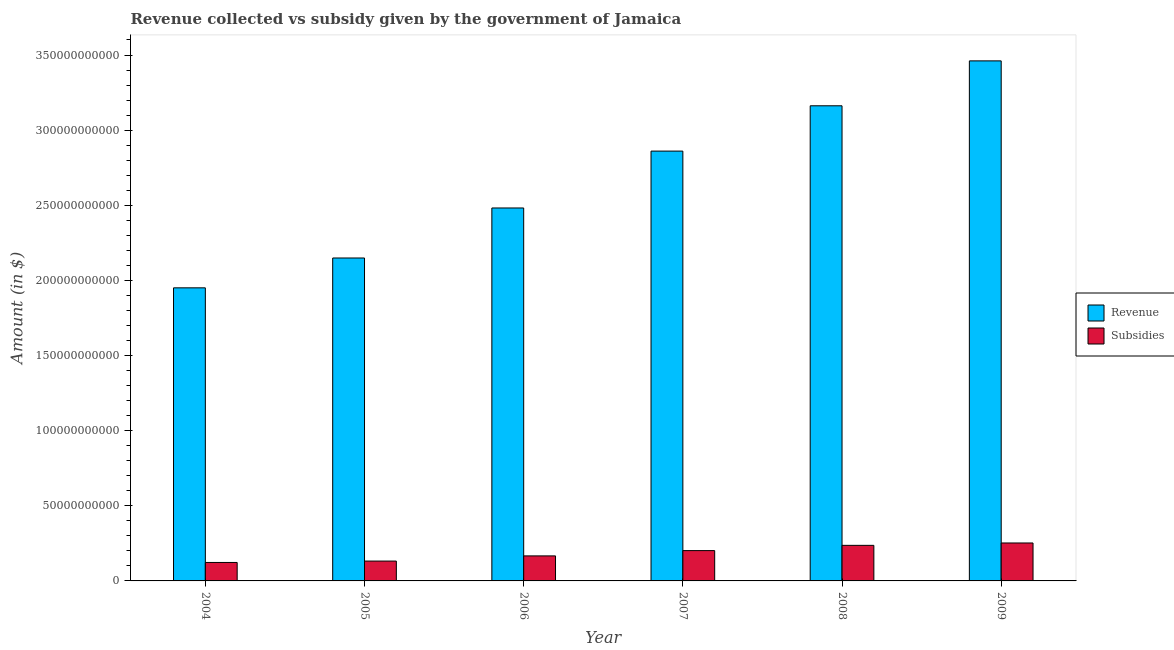How many groups of bars are there?
Offer a very short reply. 6. Are the number of bars per tick equal to the number of legend labels?
Give a very brief answer. Yes. How many bars are there on the 1st tick from the left?
Your answer should be very brief. 2. In how many cases, is the number of bars for a given year not equal to the number of legend labels?
Your answer should be very brief. 0. What is the amount of revenue collected in 2006?
Your response must be concise. 2.48e+11. Across all years, what is the maximum amount of subsidies given?
Keep it short and to the point. 2.53e+1. Across all years, what is the minimum amount of revenue collected?
Provide a succinct answer. 1.95e+11. In which year was the amount of subsidies given maximum?
Offer a terse response. 2009. In which year was the amount of revenue collected minimum?
Ensure brevity in your answer.  2004. What is the total amount of subsidies given in the graph?
Ensure brevity in your answer.  1.11e+11. What is the difference between the amount of subsidies given in 2007 and that in 2008?
Give a very brief answer. -3.50e+09. What is the difference between the amount of subsidies given in 2009 and the amount of revenue collected in 2006?
Your answer should be very brief. 8.60e+09. What is the average amount of subsidies given per year?
Keep it short and to the point. 1.85e+1. In how many years, is the amount of subsidies given greater than 350000000000 $?
Provide a short and direct response. 0. What is the ratio of the amount of revenue collected in 2007 to that in 2009?
Offer a very short reply. 0.83. What is the difference between the highest and the second highest amount of subsidies given?
Offer a terse response. 1.58e+09. What is the difference between the highest and the lowest amount of subsidies given?
Your response must be concise. 1.30e+1. In how many years, is the amount of revenue collected greater than the average amount of revenue collected taken over all years?
Make the answer very short. 3. Is the sum of the amount of revenue collected in 2004 and 2007 greater than the maximum amount of subsidies given across all years?
Provide a short and direct response. Yes. What does the 1st bar from the left in 2008 represents?
Your answer should be very brief. Revenue. What does the 1st bar from the right in 2004 represents?
Make the answer very short. Subsidies. How many bars are there?
Your answer should be very brief. 12. Are all the bars in the graph horizontal?
Offer a terse response. No. How many years are there in the graph?
Ensure brevity in your answer.  6. What is the difference between two consecutive major ticks on the Y-axis?
Provide a succinct answer. 5.00e+1. Does the graph contain any zero values?
Ensure brevity in your answer.  No. What is the title of the graph?
Provide a succinct answer. Revenue collected vs subsidy given by the government of Jamaica. Does "Revenue" appear as one of the legend labels in the graph?
Offer a terse response. Yes. What is the label or title of the X-axis?
Make the answer very short. Year. What is the label or title of the Y-axis?
Give a very brief answer. Amount (in $). What is the Amount (in $) of Revenue in 2004?
Offer a very short reply. 1.95e+11. What is the Amount (in $) of Subsidies in 2004?
Make the answer very short. 1.23e+1. What is the Amount (in $) in Revenue in 2005?
Provide a short and direct response. 2.15e+11. What is the Amount (in $) in Subsidies in 2005?
Make the answer very short. 1.32e+1. What is the Amount (in $) in Revenue in 2006?
Ensure brevity in your answer.  2.48e+11. What is the Amount (in $) in Subsidies in 2006?
Keep it short and to the point. 1.67e+1. What is the Amount (in $) of Revenue in 2007?
Your answer should be very brief. 2.86e+11. What is the Amount (in $) of Subsidies in 2007?
Give a very brief answer. 2.02e+1. What is the Amount (in $) in Revenue in 2008?
Provide a short and direct response. 3.16e+11. What is the Amount (in $) of Subsidies in 2008?
Offer a terse response. 2.37e+1. What is the Amount (in $) in Revenue in 2009?
Make the answer very short. 3.46e+11. What is the Amount (in $) of Subsidies in 2009?
Your answer should be compact. 2.53e+1. Across all years, what is the maximum Amount (in $) of Revenue?
Provide a short and direct response. 3.46e+11. Across all years, what is the maximum Amount (in $) in Subsidies?
Ensure brevity in your answer.  2.53e+1. Across all years, what is the minimum Amount (in $) of Revenue?
Provide a short and direct response. 1.95e+11. Across all years, what is the minimum Amount (in $) in Subsidies?
Make the answer very short. 1.23e+1. What is the total Amount (in $) in Revenue in the graph?
Provide a short and direct response. 1.61e+12. What is the total Amount (in $) in Subsidies in the graph?
Give a very brief answer. 1.11e+11. What is the difference between the Amount (in $) of Revenue in 2004 and that in 2005?
Your answer should be compact. -1.99e+1. What is the difference between the Amount (in $) of Subsidies in 2004 and that in 2005?
Offer a terse response. -9.25e+08. What is the difference between the Amount (in $) of Revenue in 2004 and that in 2006?
Offer a very short reply. -5.32e+1. What is the difference between the Amount (in $) in Subsidies in 2004 and that in 2006?
Your answer should be compact. -4.37e+09. What is the difference between the Amount (in $) of Revenue in 2004 and that in 2007?
Keep it short and to the point. -9.10e+1. What is the difference between the Amount (in $) of Subsidies in 2004 and that in 2007?
Your answer should be very brief. -7.89e+09. What is the difference between the Amount (in $) in Revenue in 2004 and that in 2008?
Your answer should be very brief. -1.21e+11. What is the difference between the Amount (in $) in Subsidies in 2004 and that in 2008?
Offer a terse response. -1.14e+1. What is the difference between the Amount (in $) in Revenue in 2004 and that in 2009?
Make the answer very short. -1.51e+11. What is the difference between the Amount (in $) in Subsidies in 2004 and that in 2009?
Make the answer very short. -1.30e+1. What is the difference between the Amount (in $) of Revenue in 2005 and that in 2006?
Provide a succinct answer. -3.33e+1. What is the difference between the Amount (in $) of Subsidies in 2005 and that in 2006?
Keep it short and to the point. -3.44e+09. What is the difference between the Amount (in $) of Revenue in 2005 and that in 2007?
Provide a succinct answer. -7.11e+1. What is the difference between the Amount (in $) in Subsidies in 2005 and that in 2007?
Ensure brevity in your answer.  -6.96e+09. What is the difference between the Amount (in $) of Revenue in 2005 and that in 2008?
Give a very brief answer. -1.01e+11. What is the difference between the Amount (in $) in Subsidies in 2005 and that in 2008?
Keep it short and to the point. -1.05e+1. What is the difference between the Amount (in $) in Revenue in 2005 and that in 2009?
Ensure brevity in your answer.  -1.31e+11. What is the difference between the Amount (in $) of Subsidies in 2005 and that in 2009?
Ensure brevity in your answer.  -1.20e+1. What is the difference between the Amount (in $) in Revenue in 2006 and that in 2007?
Keep it short and to the point. -3.78e+1. What is the difference between the Amount (in $) in Subsidies in 2006 and that in 2007?
Provide a short and direct response. -3.52e+09. What is the difference between the Amount (in $) of Revenue in 2006 and that in 2008?
Provide a short and direct response. -6.80e+1. What is the difference between the Amount (in $) of Subsidies in 2006 and that in 2008?
Keep it short and to the point. -7.02e+09. What is the difference between the Amount (in $) in Revenue in 2006 and that in 2009?
Your response must be concise. -9.79e+1. What is the difference between the Amount (in $) of Subsidies in 2006 and that in 2009?
Offer a terse response. -8.60e+09. What is the difference between the Amount (in $) of Revenue in 2007 and that in 2008?
Your answer should be compact. -3.02e+1. What is the difference between the Amount (in $) of Subsidies in 2007 and that in 2008?
Provide a short and direct response. -3.50e+09. What is the difference between the Amount (in $) in Revenue in 2007 and that in 2009?
Provide a short and direct response. -6.01e+1. What is the difference between the Amount (in $) of Subsidies in 2007 and that in 2009?
Keep it short and to the point. -5.08e+09. What is the difference between the Amount (in $) of Revenue in 2008 and that in 2009?
Keep it short and to the point. -2.99e+1. What is the difference between the Amount (in $) in Subsidies in 2008 and that in 2009?
Your answer should be very brief. -1.58e+09. What is the difference between the Amount (in $) in Revenue in 2004 and the Amount (in $) in Subsidies in 2005?
Your answer should be compact. 1.82e+11. What is the difference between the Amount (in $) in Revenue in 2004 and the Amount (in $) in Subsidies in 2006?
Offer a very short reply. 1.78e+11. What is the difference between the Amount (in $) of Revenue in 2004 and the Amount (in $) of Subsidies in 2007?
Give a very brief answer. 1.75e+11. What is the difference between the Amount (in $) in Revenue in 2004 and the Amount (in $) in Subsidies in 2008?
Provide a succinct answer. 1.71e+11. What is the difference between the Amount (in $) in Revenue in 2004 and the Amount (in $) in Subsidies in 2009?
Your response must be concise. 1.70e+11. What is the difference between the Amount (in $) in Revenue in 2005 and the Amount (in $) in Subsidies in 2006?
Make the answer very short. 1.98e+11. What is the difference between the Amount (in $) of Revenue in 2005 and the Amount (in $) of Subsidies in 2007?
Make the answer very short. 1.95e+11. What is the difference between the Amount (in $) of Revenue in 2005 and the Amount (in $) of Subsidies in 2008?
Your response must be concise. 1.91e+11. What is the difference between the Amount (in $) in Revenue in 2005 and the Amount (in $) in Subsidies in 2009?
Provide a short and direct response. 1.90e+11. What is the difference between the Amount (in $) of Revenue in 2006 and the Amount (in $) of Subsidies in 2007?
Give a very brief answer. 2.28e+11. What is the difference between the Amount (in $) in Revenue in 2006 and the Amount (in $) in Subsidies in 2008?
Keep it short and to the point. 2.25e+11. What is the difference between the Amount (in $) of Revenue in 2006 and the Amount (in $) of Subsidies in 2009?
Ensure brevity in your answer.  2.23e+11. What is the difference between the Amount (in $) of Revenue in 2007 and the Amount (in $) of Subsidies in 2008?
Keep it short and to the point. 2.62e+11. What is the difference between the Amount (in $) of Revenue in 2007 and the Amount (in $) of Subsidies in 2009?
Ensure brevity in your answer.  2.61e+11. What is the difference between the Amount (in $) in Revenue in 2008 and the Amount (in $) in Subsidies in 2009?
Offer a terse response. 2.91e+11. What is the average Amount (in $) of Revenue per year?
Ensure brevity in your answer.  2.68e+11. What is the average Amount (in $) in Subsidies per year?
Your answer should be very brief. 1.85e+1. In the year 2004, what is the difference between the Amount (in $) of Revenue and Amount (in $) of Subsidies?
Make the answer very short. 1.83e+11. In the year 2005, what is the difference between the Amount (in $) of Revenue and Amount (in $) of Subsidies?
Your response must be concise. 2.02e+11. In the year 2006, what is the difference between the Amount (in $) in Revenue and Amount (in $) in Subsidies?
Give a very brief answer. 2.32e+11. In the year 2007, what is the difference between the Amount (in $) of Revenue and Amount (in $) of Subsidies?
Provide a succinct answer. 2.66e+11. In the year 2008, what is the difference between the Amount (in $) of Revenue and Amount (in $) of Subsidies?
Provide a short and direct response. 2.93e+11. In the year 2009, what is the difference between the Amount (in $) of Revenue and Amount (in $) of Subsidies?
Offer a very short reply. 3.21e+11. What is the ratio of the Amount (in $) of Revenue in 2004 to that in 2005?
Make the answer very short. 0.91. What is the ratio of the Amount (in $) in Revenue in 2004 to that in 2006?
Make the answer very short. 0.79. What is the ratio of the Amount (in $) in Subsidies in 2004 to that in 2006?
Provide a short and direct response. 0.74. What is the ratio of the Amount (in $) of Revenue in 2004 to that in 2007?
Offer a very short reply. 0.68. What is the ratio of the Amount (in $) in Subsidies in 2004 to that in 2007?
Offer a terse response. 0.61. What is the ratio of the Amount (in $) in Revenue in 2004 to that in 2008?
Make the answer very short. 0.62. What is the ratio of the Amount (in $) in Subsidies in 2004 to that in 2008?
Ensure brevity in your answer.  0.52. What is the ratio of the Amount (in $) of Revenue in 2004 to that in 2009?
Ensure brevity in your answer.  0.56. What is the ratio of the Amount (in $) of Subsidies in 2004 to that in 2009?
Your response must be concise. 0.49. What is the ratio of the Amount (in $) of Revenue in 2005 to that in 2006?
Keep it short and to the point. 0.87. What is the ratio of the Amount (in $) in Subsidies in 2005 to that in 2006?
Offer a terse response. 0.79. What is the ratio of the Amount (in $) in Revenue in 2005 to that in 2007?
Ensure brevity in your answer.  0.75. What is the ratio of the Amount (in $) in Subsidies in 2005 to that in 2007?
Provide a short and direct response. 0.65. What is the ratio of the Amount (in $) in Revenue in 2005 to that in 2008?
Offer a very short reply. 0.68. What is the ratio of the Amount (in $) in Subsidies in 2005 to that in 2008?
Make the answer very short. 0.56. What is the ratio of the Amount (in $) in Revenue in 2005 to that in 2009?
Your answer should be very brief. 0.62. What is the ratio of the Amount (in $) in Subsidies in 2005 to that in 2009?
Keep it short and to the point. 0.52. What is the ratio of the Amount (in $) in Revenue in 2006 to that in 2007?
Provide a short and direct response. 0.87. What is the ratio of the Amount (in $) of Subsidies in 2006 to that in 2007?
Your response must be concise. 0.83. What is the ratio of the Amount (in $) of Revenue in 2006 to that in 2008?
Keep it short and to the point. 0.78. What is the ratio of the Amount (in $) in Subsidies in 2006 to that in 2008?
Give a very brief answer. 0.7. What is the ratio of the Amount (in $) in Revenue in 2006 to that in 2009?
Give a very brief answer. 0.72. What is the ratio of the Amount (in $) in Subsidies in 2006 to that in 2009?
Offer a very short reply. 0.66. What is the ratio of the Amount (in $) of Revenue in 2007 to that in 2008?
Ensure brevity in your answer.  0.9. What is the ratio of the Amount (in $) of Subsidies in 2007 to that in 2008?
Provide a short and direct response. 0.85. What is the ratio of the Amount (in $) of Revenue in 2007 to that in 2009?
Offer a very short reply. 0.83. What is the ratio of the Amount (in $) of Subsidies in 2007 to that in 2009?
Offer a terse response. 0.8. What is the ratio of the Amount (in $) in Revenue in 2008 to that in 2009?
Your answer should be compact. 0.91. What is the ratio of the Amount (in $) in Subsidies in 2008 to that in 2009?
Your response must be concise. 0.94. What is the difference between the highest and the second highest Amount (in $) in Revenue?
Provide a short and direct response. 2.99e+1. What is the difference between the highest and the second highest Amount (in $) in Subsidies?
Offer a terse response. 1.58e+09. What is the difference between the highest and the lowest Amount (in $) of Revenue?
Ensure brevity in your answer.  1.51e+11. What is the difference between the highest and the lowest Amount (in $) of Subsidies?
Give a very brief answer. 1.30e+1. 